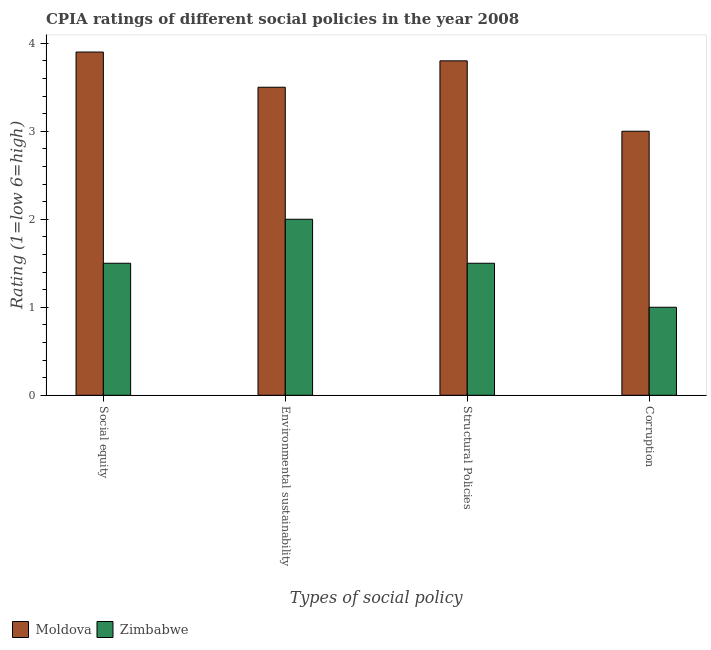How many different coloured bars are there?
Your answer should be very brief. 2. How many bars are there on the 2nd tick from the right?
Your answer should be very brief. 2. What is the label of the 4th group of bars from the left?
Your response must be concise. Corruption. What is the cpia rating of structural policies in Zimbabwe?
Your answer should be compact. 1.5. Across all countries, what is the maximum cpia rating of corruption?
Your answer should be compact. 3. Across all countries, what is the minimum cpia rating of structural policies?
Your response must be concise. 1.5. In which country was the cpia rating of corruption maximum?
Offer a terse response. Moldova. In which country was the cpia rating of structural policies minimum?
Ensure brevity in your answer.  Zimbabwe. What is the total cpia rating of social equity in the graph?
Your answer should be very brief. 5.4. In how many countries, is the cpia rating of corruption greater than 1.2 ?
Make the answer very short. 1. What is the ratio of the cpia rating of social equity in Moldova to that in Zimbabwe?
Your response must be concise. 2.6. Is the cpia rating of structural policies in Zimbabwe less than that in Moldova?
Make the answer very short. Yes. What is the difference between the highest and the second highest cpia rating of environmental sustainability?
Your response must be concise. 1.5. What is the difference between the highest and the lowest cpia rating of corruption?
Your answer should be very brief. 2. In how many countries, is the cpia rating of structural policies greater than the average cpia rating of structural policies taken over all countries?
Give a very brief answer. 1. Is the sum of the cpia rating of structural policies in Zimbabwe and Moldova greater than the maximum cpia rating of environmental sustainability across all countries?
Make the answer very short. Yes. Is it the case that in every country, the sum of the cpia rating of social equity and cpia rating of environmental sustainability is greater than the sum of cpia rating of corruption and cpia rating of structural policies?
Keep it short and to the point. No. What does the 1st bar from the left in Environmental sustainability represents?
Provide a short and direct response. Moldova. What does the 2nd bar from the right in Social equity represents?
Ensure brevity in your answer.  Moldova. Is it the case that in every country, the sum of the cpia rating of social equity and cpia rating of environmental sustainability is greater than the cpia rating of structural policies?
Provide a succinct answer. Yes. How many bars are there?
Make the answer very short. 8. How many countries are there in the graph?
Keep it short and to the point. 2. Are the values on the major ticks of Y-axis written in scientific E-notation?
Offer a terse response. No. How are the legend labels stacked?
Ensure brevity in your answer.  Horizontal. What is the title of the graph?
Keep it short and to the point. CPIA ratings of different social policies in the year 2008. Does "Malta" appear as one of the legend labels in the graph?
Provide a succinct answer. No. What is the label or title of the X-axis?
Give a very brief answer. Types of social policy. What is the Rating (1=low 6=high) in Zimbabwe in Social equity?
Your response must be concise. 1.5. What is the Rating (1=low 6=high) in Zimbabwe in Environmental sustainability?
Provide a succinct answer. 2. What is the Rating (1=low 6=high) in Moldova in Structural Policies?
Your answer should be very brief. 3.8. What is the Rating (1=low 6=high) in Zimbabwe in Corruption?
Ensure brevity in your answer.  1. Across all Types of social policy, what is the maximum Rating (1=low 6=high) in Zimbabwe?
Make the answer very short. 2. Across all Types of social policy, what is the minimum Rating (1=low 6=high) in Moldova?
Keep it short and to the point. 3. What is the difference between the Rating (1=low 6=high) of Zimbabwe in Social equity and that in Environmental sustainability?
Your answer should be very brief. -0.5. What is the difference between the Rating (1=low 6=high) of Zimbabwe in Social equity and that in Structural Policies?
Provide a short and direct response. 0. What is the difference between the Rating (1=low 6=high) in Moldova in Social equity and that in Corruption?
Give a very brief answer. 0.9. What is the difference between the Rating (1=low 6=high) in Zimbabwe in Social equity and that in Corruption?
Your answer should be compact. 0.5. What is the difference between the Rating (1=low 6=high) of Moldova in Environmental sustainability and that in Structural Policies?
Offer a terse response. -0.3. What is the difference between the Rating (1=low 6=high) of Zimbabwe in Environmental sustainability and that in Structural Policies?
Provide a short and direct response. 0.5. What is the difference between the Rating (1=low 6=high) in Moldova in Structural Policies and that in Corruption?
Your answer should be very brief. 0.8. What is the difference between the Rating (1=low 6=high) of Moldova in Social equity and the Rating (1=low 6=high) of Zimbabwe in Structural Policies?
Your response must be concise. 2.4. What is the difference between the Rating (1=low 6=high) in Moldova in Social equity and the Rating (1=low 6=high) in Zimbabwe in Corruption?
Provide a short and direct response. 2.9. What is the difference between the Rating (1=low 6=high) in Moldova in Environmental sustainability and the Rating (1=low 6=high) in Zimbabwe in Structural Policies?
Ensure brevity in your answer.  2. What is the difference between the Rating (1=low 6=high) in Moldova in Environmental sustainability and the Rating (1=low 6=high) in Zimbabwe in Corruption?
Provide a succinct answer. 2.5. What is the average Rating (1=low 6=high) of Moldova per Types of social policy?
Keep it short and to the point. 3.55. What is the difference between the Rating (1=low 6=high) in Moldova and Rating (1=low 6=high) in Zimbabwe in Social equity?
Provide a succinct answer. 2.4. What is the difference between the Rating (1=low 6=high) of Moldova and Rating (1=low 6=high) of Zimbabwe in Structural Policies?
Keep it short and to the point. 2.3. What is the difference between the Rating (1=low 6=high) of Moldova and Rating (1=low 6=high) of Zimbabwe in Corruption?
Keep it short and to the point. 2. What is the ratio of the Rating (1=low 6=high) in Moldova in Social equity to that in Environmental sustainability?
Ensure brevity in your answer.  1.11. What is the ratio of the Rating (1=low 6=high) of Zimbabwe in Social equity to that in Environmental sustainability?
Ensure brevity in your answer.  0.75. What is the ratio of the Rating (1=low 6=high) of Moldova in Social equity to that in Structural Policies?
Keep it short and to the point. 1.03. What is the ratio of the Rating (1=low 6=high) of Moldova in Social equity to that in Corruption?
Your answer should be very brief. 1.3. What is the ratio of the Rating (1=low 6=high) in Moldova in Environmental sustainability to that in Structural Policies?
Make the answer very short. 0.92. What is the ratio of the Rating (1=low 6=high) of Zimbabwe in Environmental sustainability to that in Structural Policies?
Offer a terse response. 1.33. What is the ratio of the Rating (1=low 6=high) of Zimbabwe in Environmental sustainability to that in Corruption?
Your answer should be compact. 2. What is the ratio of the Rating (1=low 6=high) of Moldova in Structural Policies to that in Corruption?
Your response must be concise. 1.27. What is the difference between the highest and the second highest Rating (1=low 6=high) of Zimbabwe?
Make the answer very short. 0.5. What is the difference between the highest and the lowest Rating (1=low 6=high) in Zimbabwe?
Your answer should be very brief. 1. 